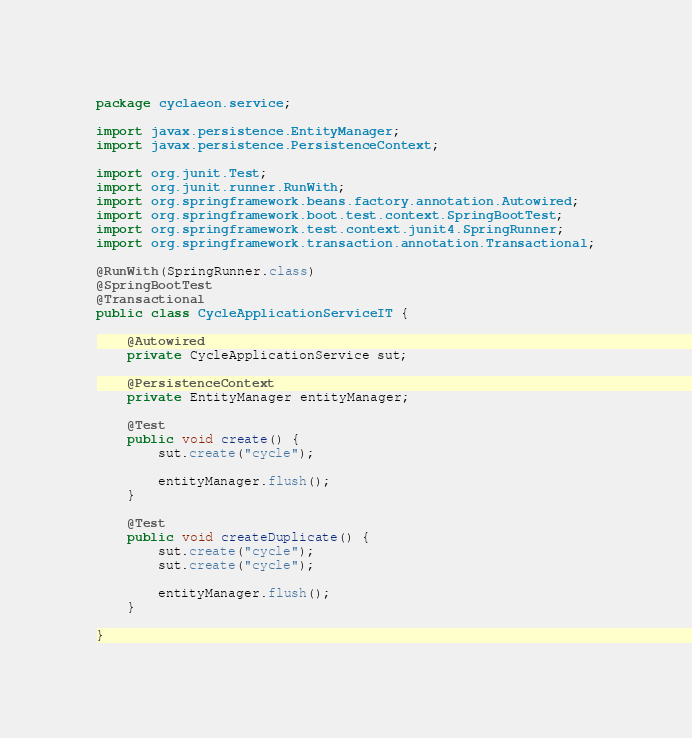<code> <loc_0><loc_0><loc_500><loc_500><_Java_>package cyclaeon.service;

import javax.persistence.EntityManager;
import javax.persistence.PersistenceContext;

import org.junit.Test;
import org.junit.runner.RunWith;
import org.springframework.beans.factory.annotation.Autowired;
import org.springframework.boot.test.context.SpringBootTest;
import org.springframework.test.context.junit4.SpringRunner;
import org.springframework.transaction.annotation.Transactional;

@RunWith(SpringRunner.class)
@SpringBootTest
@Transactional
public class CycleApplicationServiceIT {

	@Autowired
	private CycleApplicationService sut;

	@PersistenceContext
	private EntityManager entityManager;

	@Test
	public void create() {
		sut.create("cycle");

		entityManager.flush();
	}

	@Test
	public void createDuplicate() {
		sut.create("cycle");
		sut.create("cycle");

		entityManager.flush();
	}

}</code> 